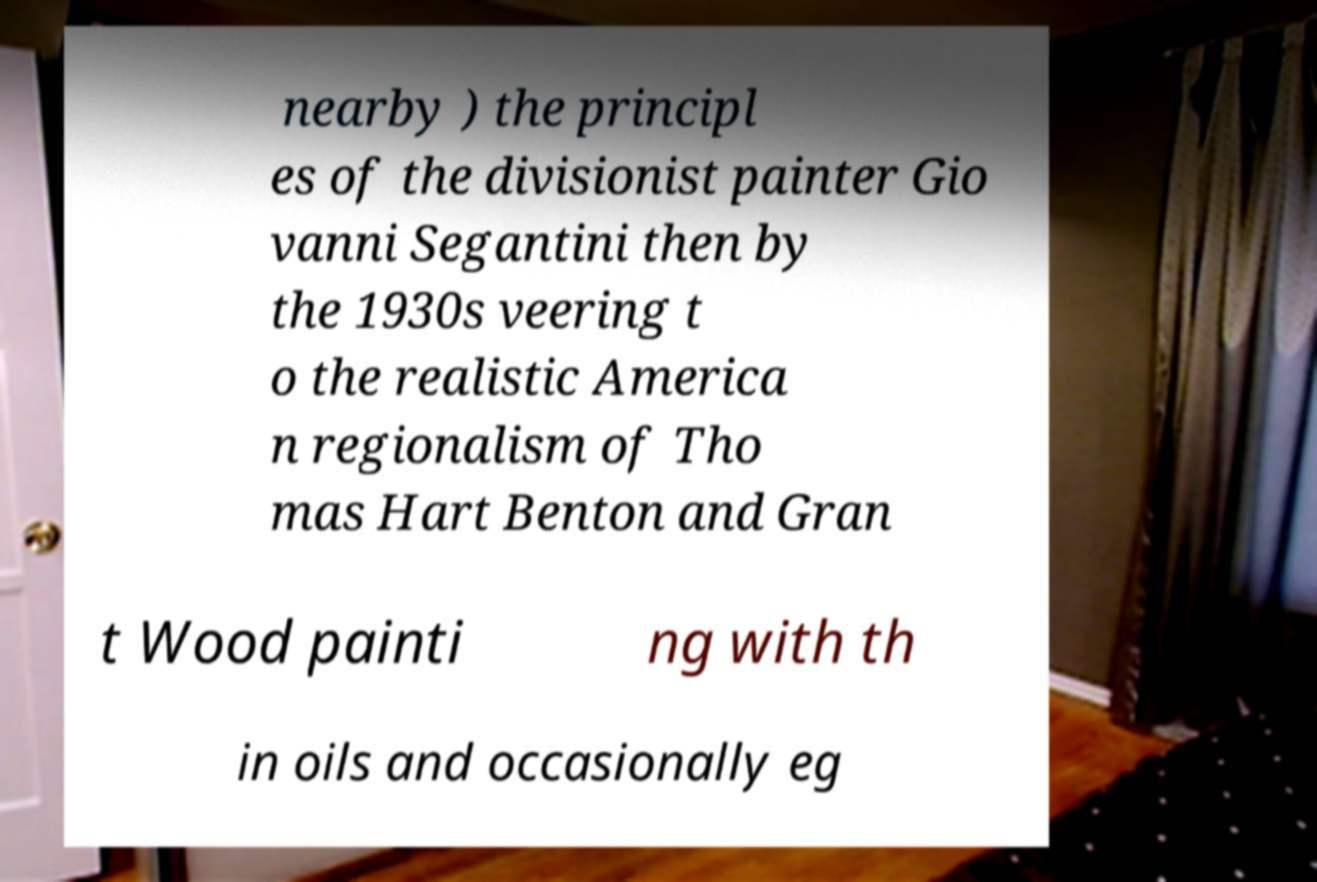For documentation purposes, I need the text within this image transcribed. Could you provide that? nearby ) the principl es of the divisionist painter Gio vanni Segantini then by the 1930s veering t o the realistic America n regionalism of Tho mas Hart Benton and Gran t Wood painti ng with th in oils and occasionally eg 